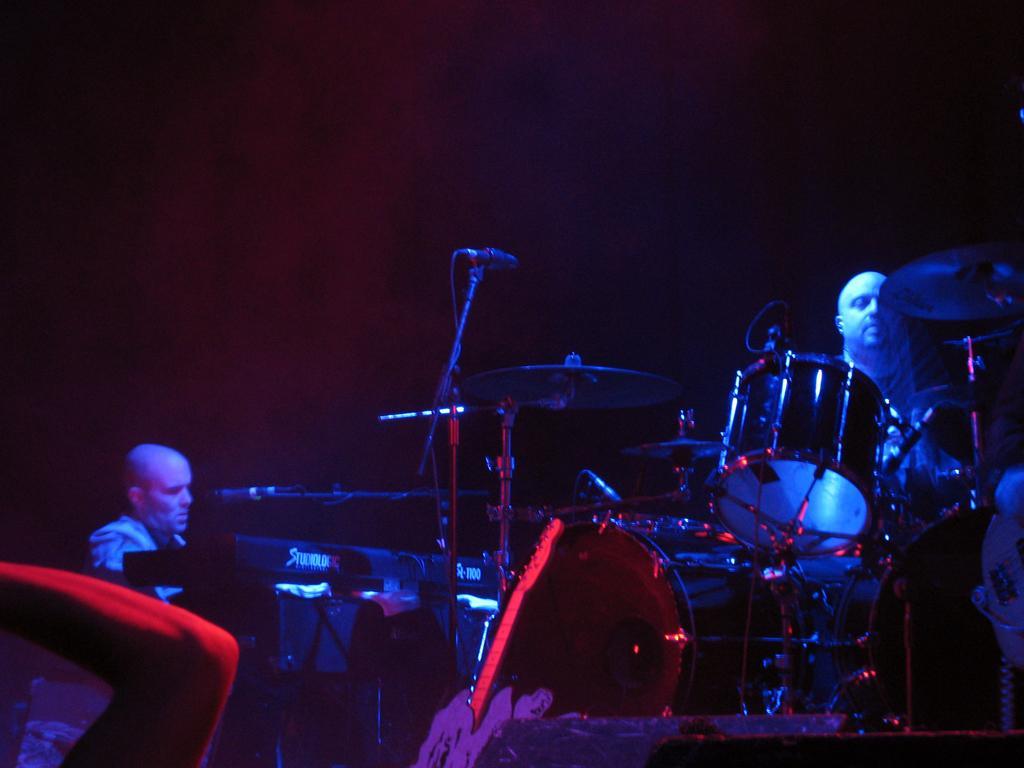Could you give a brief overview of what you see in this image? In this picture we can see few people, in front of them we can see musical instruments and a microphone. 